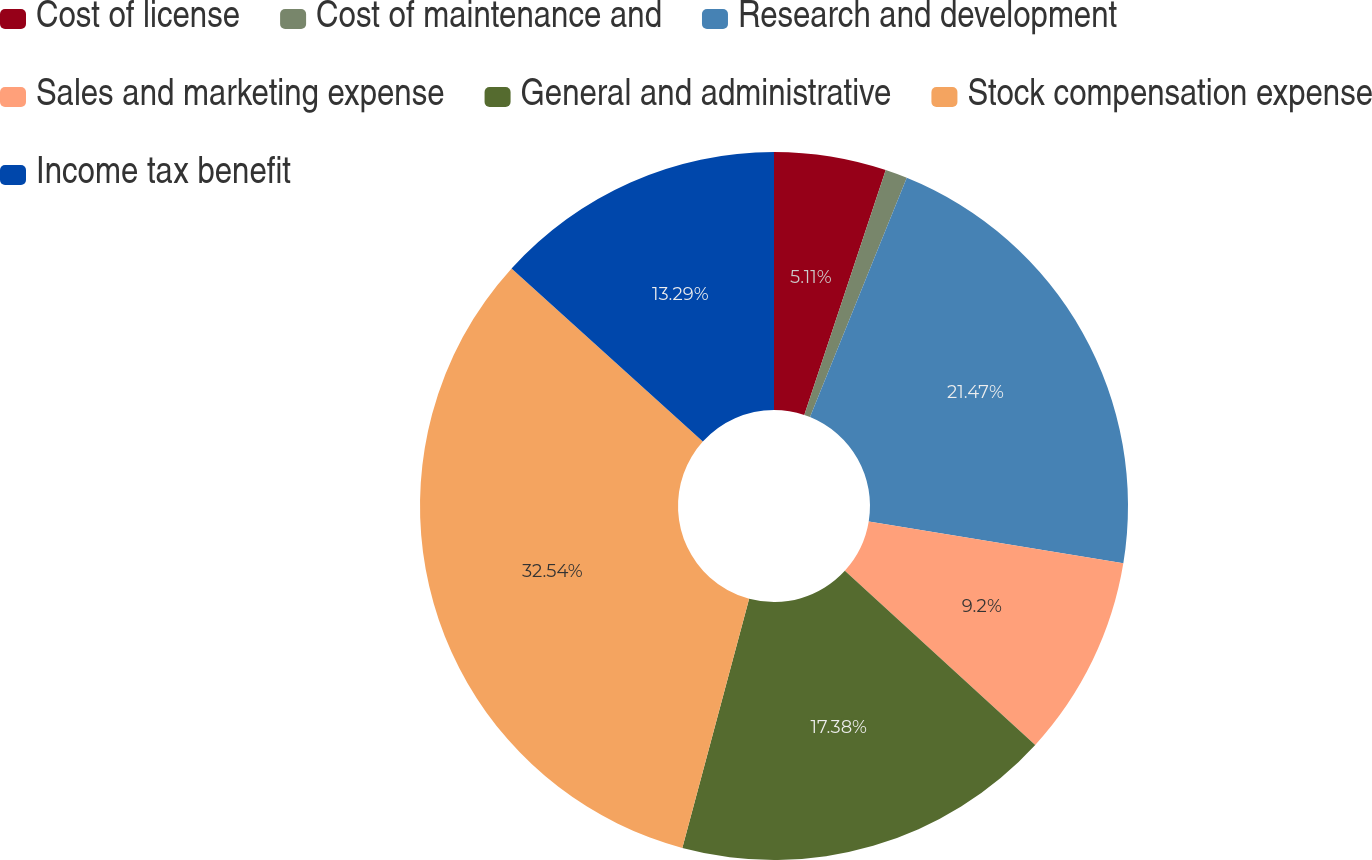<chart> <loc_0><loc_0><loc_500><loc_500><pie_chart><fcel>Cost of license<fcel>Cost of maintenance and<fcel>Research and development<fcel>Sales and marketing expense<fcel>General and administrative<fcel>Stock compensation expense<fcel>Income tax benefit<nl><fcel>5.11%<fcel>1.01%<fcel>21.47%<fcel>9.2%<fcel>17.38%<fcel>32.54%<fcel>13.29%<nl></chart> 